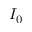Convert formula to latex. <formula><loc_0><loc_0><loc_500><loc_500>I _ { 0 }</formula> 